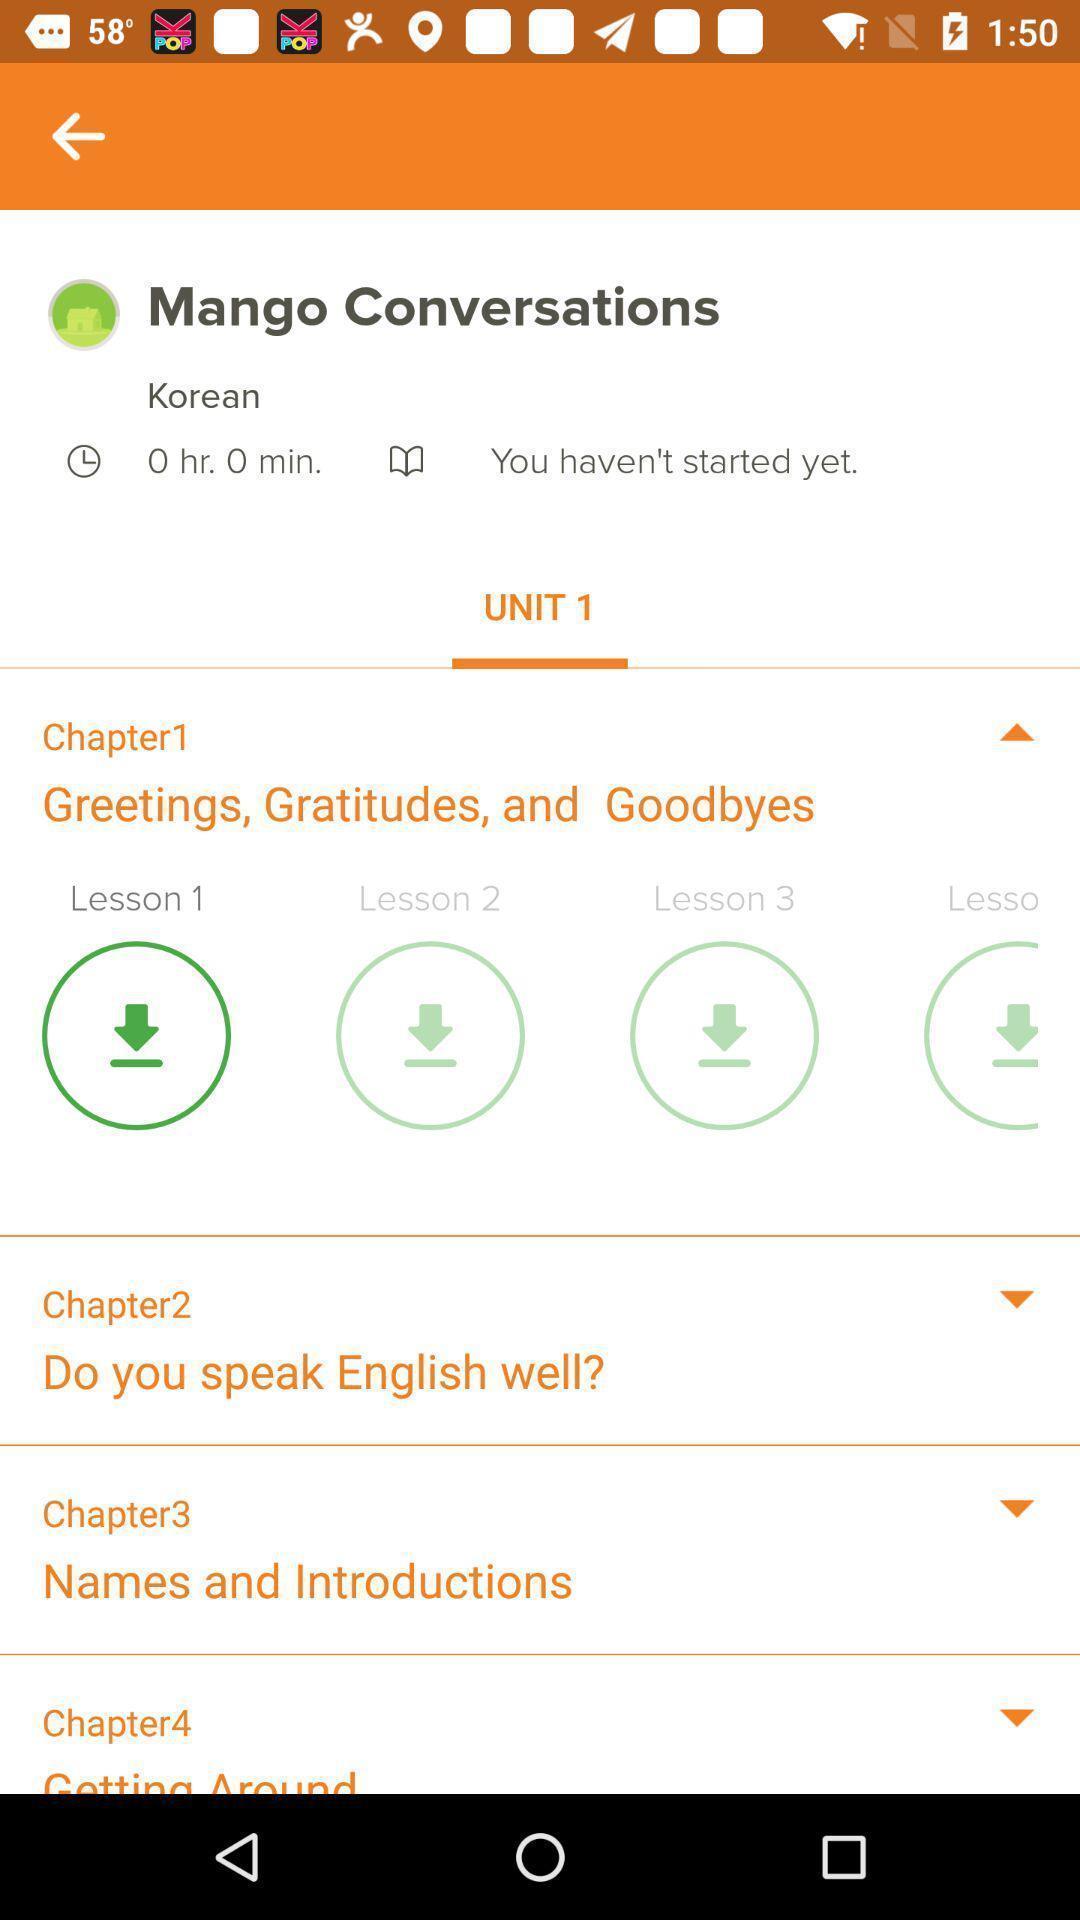Provide a description of this screenshot. Screen display various lessons in a learning app. 